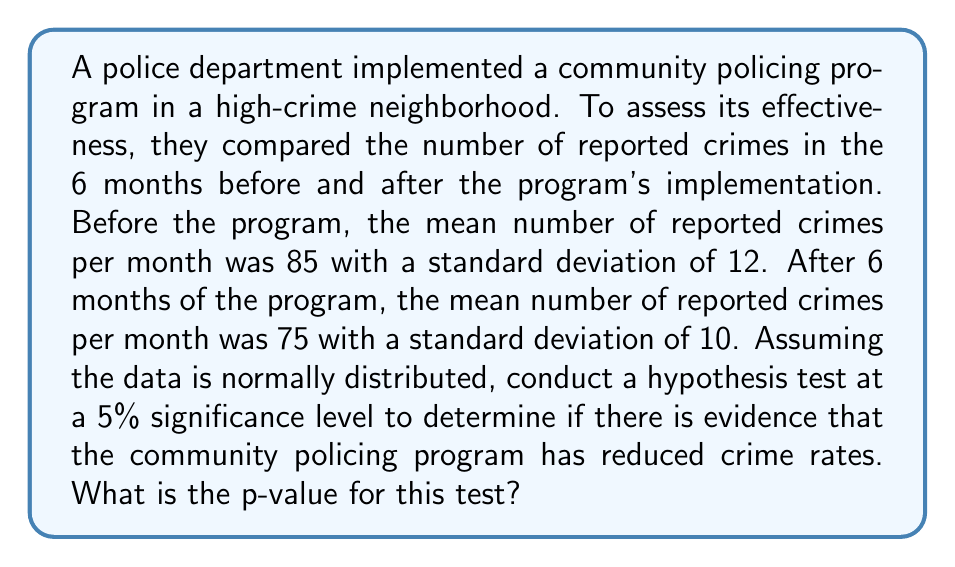Teach me how to tackle this problem. To conduct this hypothesis test, we'll follow these steps:

1) Define the null and alternative hypotheses:
   $H_0: \mu_1 - \mu_2 = 0$ (no difference in crime rates)
   $H_a: \mu_1 - \mu_2 > 0$ (crime rates have decreased)

2) Calculate the pooled standard error:
   $SE = \sqrt{\frac{s_1^2}{n_1} + \frac{s_2^2}{n_2}}$
   where $s_1 = 12$, $s_2 = 10$, and $n_1 = n_2 = 6$
   
   $SE = \sqrt{\frac{12^2}{6} + \frac{10^2}{6}} = \sqrt{24 + 16.67} = \sqrt{40.67} \approx 6.38$

3) Calculate the t-statistic:
   $t = \frac{(\bar{x}_1 - \bar{x}_2) - 0}{SE} = \frac{85 - 75}{6.38} \approx 1.57$

4) Determine the degrees of freedom:
   $df = n_1 + n_2 - 2 = 6 + 6 - 2 = 10$

5) Find the p-value:
   Using a t-distribution table or calculator with 10 degrees of freedom and t ≈ 1.57, we find the one-tailed p-value is approximately 0.0735.

The p-value (0.0735) is greater than the significance level (0.05), so we fail to reject the null hypothesis. This means we don't have sufficient evidence to conclude that the community policing program has significantly reduced crime rates at the 5% significance level.
Answer: 0.0735 